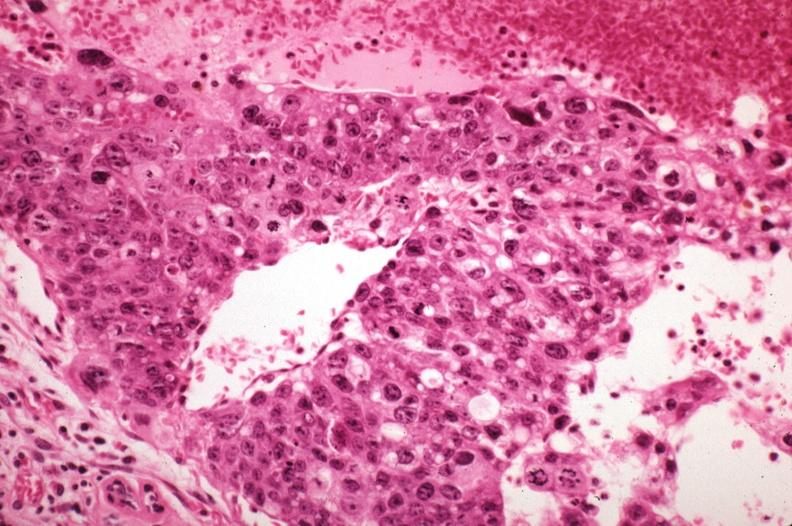what is present?
Answer the question using a single word or phrase. Metastatic carcinoma 